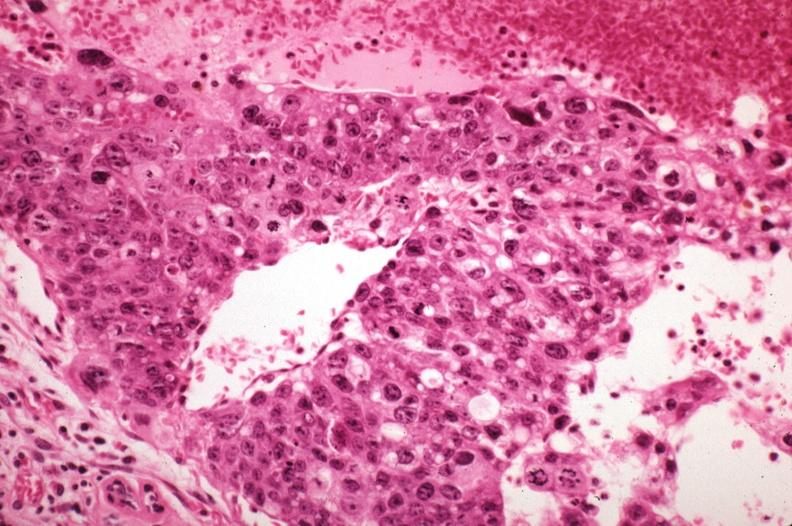what is present?
Answer the question using a single word or phrase. Metastatic carcinoma 